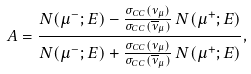Convert formula to latex. <formula><loc_0><loc_0><loc_500><loc_500>A = \frac { N ( \mu ^ { - } ; E ) - \frac { \sigma _ { C C } ( \nu _ { \mu } ) } { \sigma _ { C C } ( \overline { \nu } _ { \mu } ) } \, N ( \mu ^ { + } ; E ) } { N ( \mu ^ { - } ; E ) + \frac { \sigma _ { C C } ( \nu _ { \mu } ) } { \sigma _ { C C } ( \overline { \nu } _ { \mu } ) } \, N ( \mu ^ { + } ; E ) } ,</formula> 